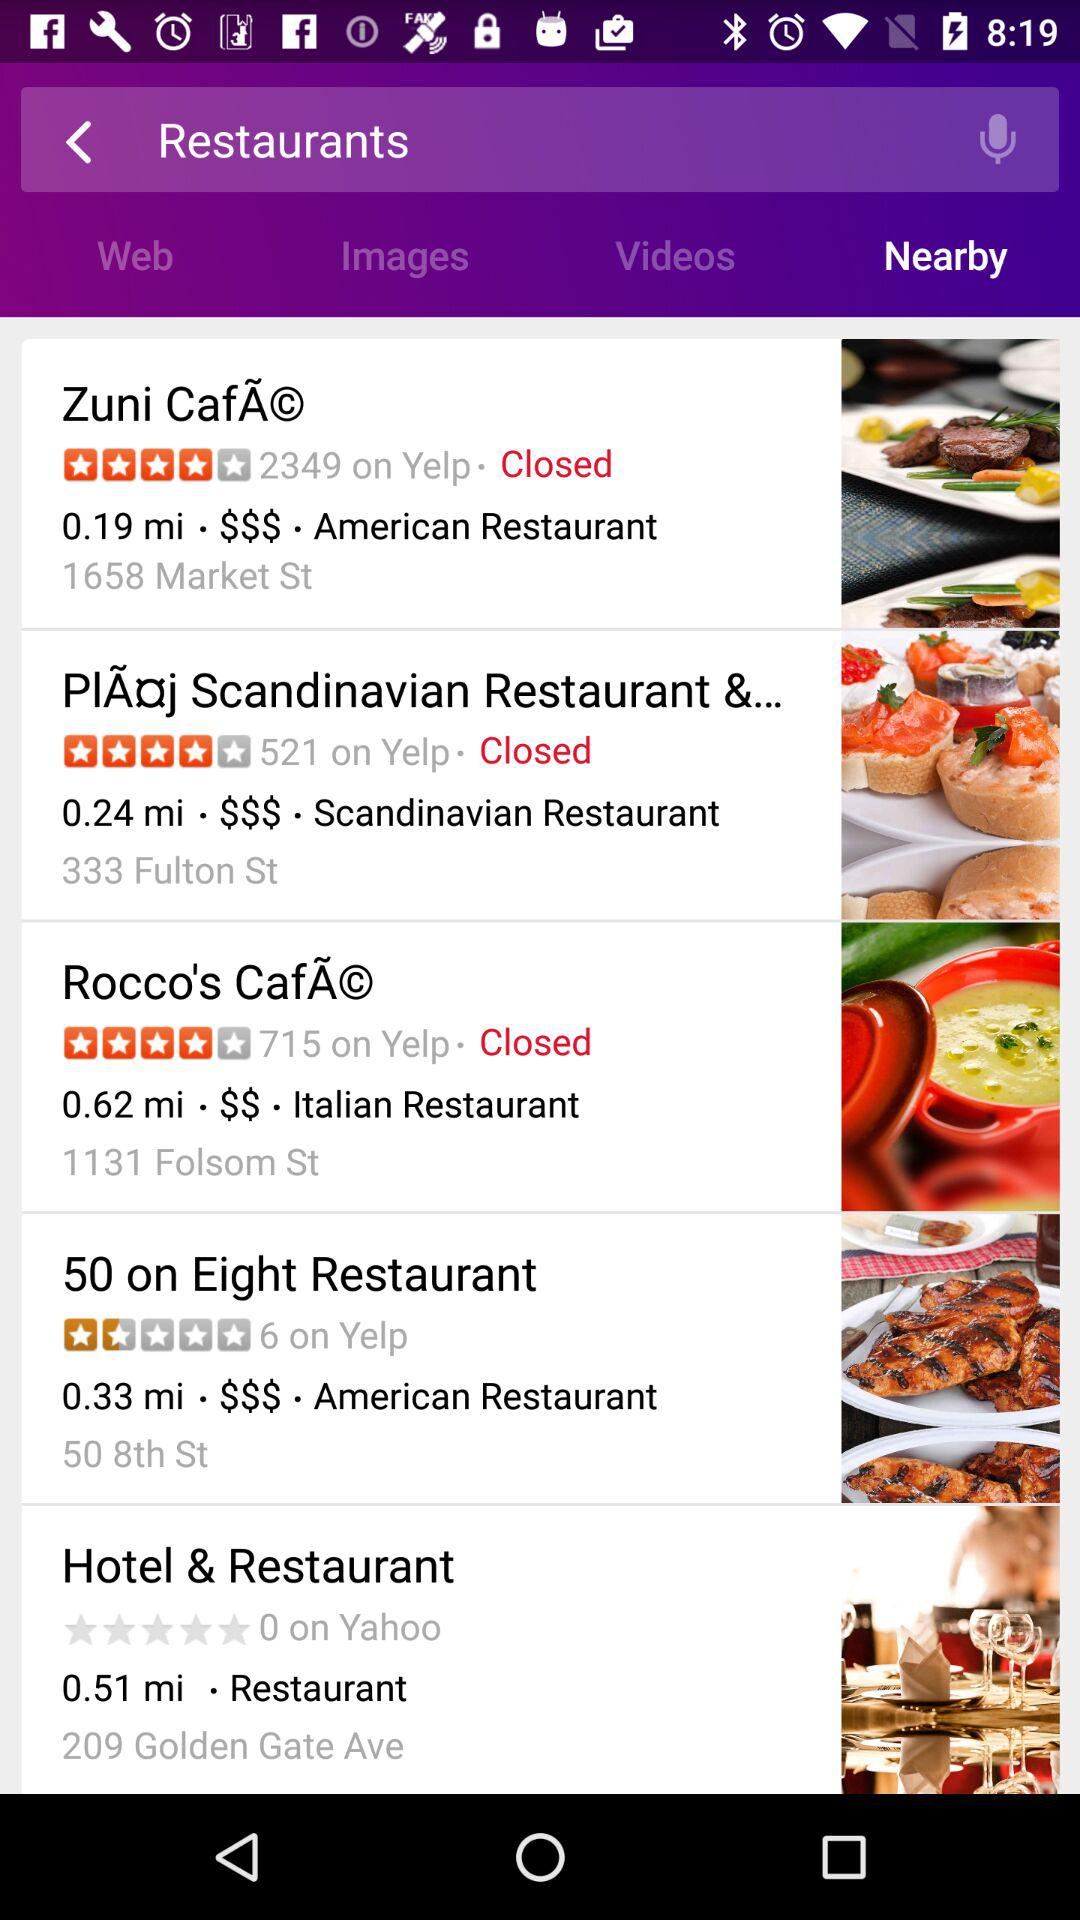What's the address of "50 on Eight Restaurant"? The address is 50 8th St. 